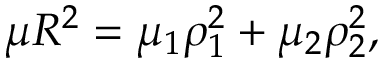Convert formula to latex. <formula><loc_0><loc_0><loc_500><loc_500>\mu R ^ { 2 } = \mu _ { 1 } \rho _ { 1 } ^ { 2 } + \mu _ { 2 } \rho _ { 2 } ^ { 2 } ,</formula> 